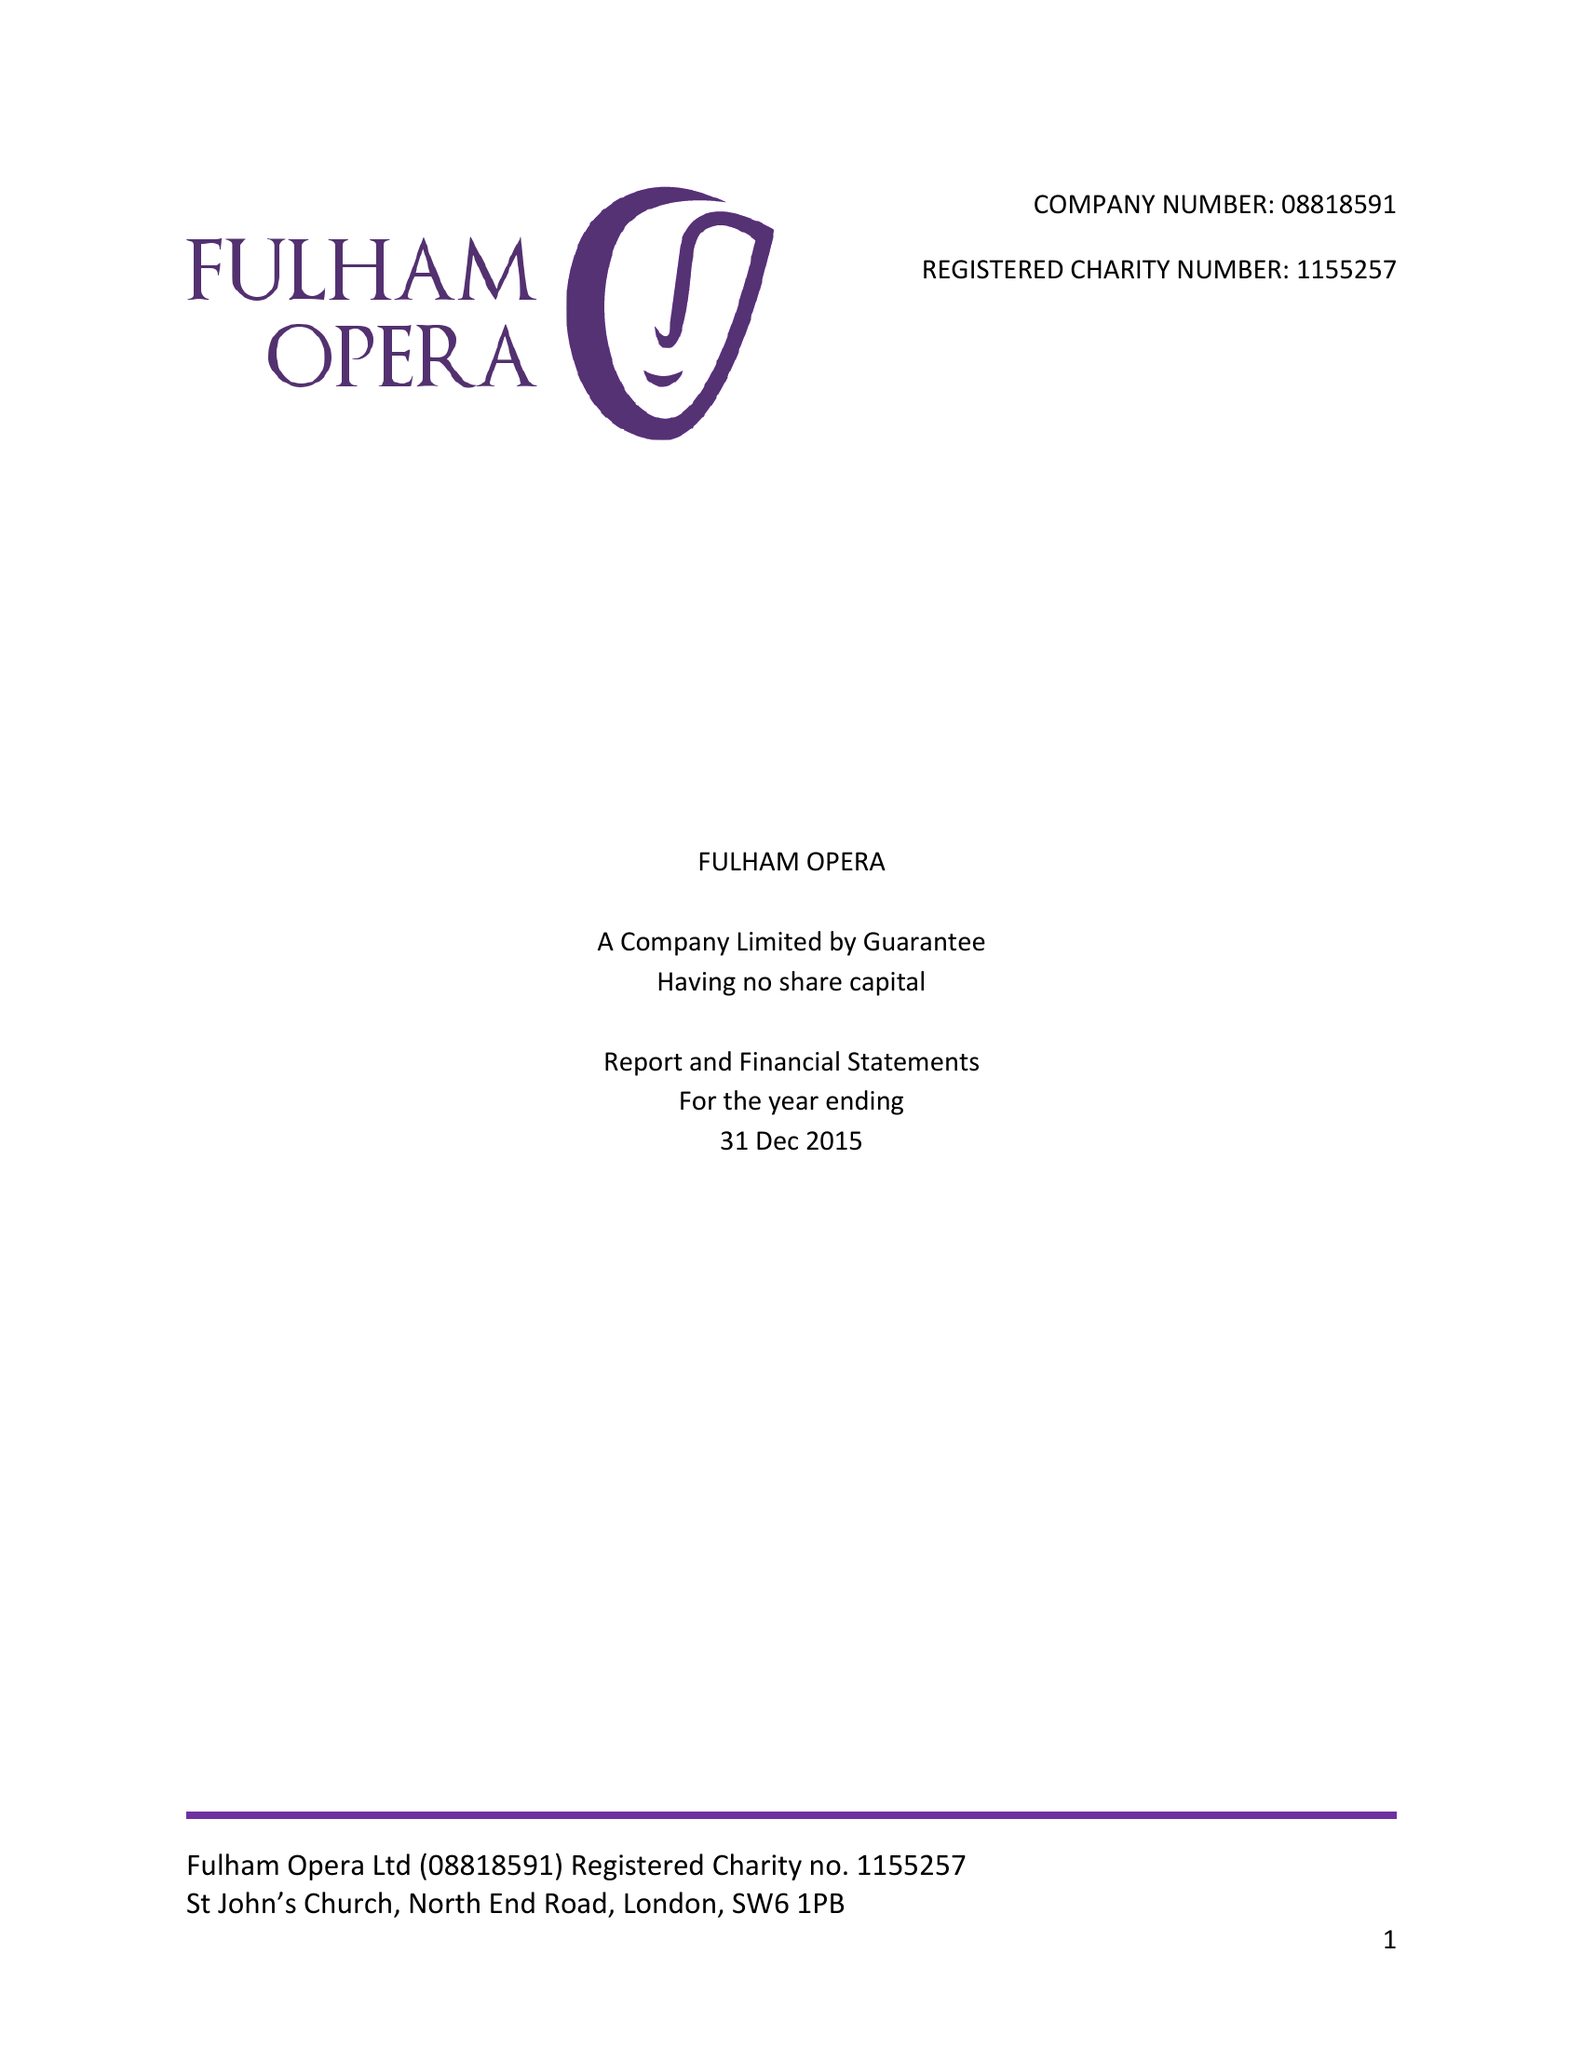What is the value for the address__post_town?
Answer the question using a single word or phrase. LONDON 